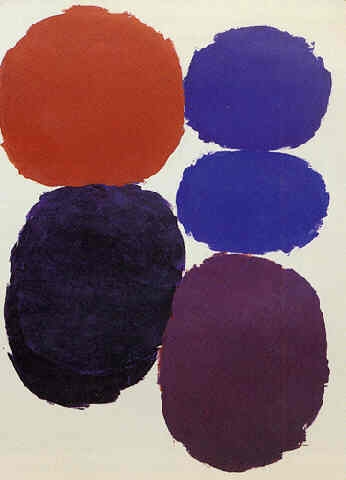Analyze the image in a comprehensive and detailed manner. The image features a striking composition of five circles, each distinct in size and hue, set against a neutral backdrop that enhances their vibrancy. The largest circle is a vivid red at the base, suggesting a grounding effect, while the sequential arrangement of blue, dark blue, and purple as we move upward conveys a sense of ascension or depth. The smallest circle, orange and placed at the apex, perhaps symbolizes a focal point or climax. This artwork uses minimalistic elements to explore themes of balance, rhythm, and possibly hierarchy, drawing viewers into a contemplation of spatial dynamics and the emotional resonances of colors. 